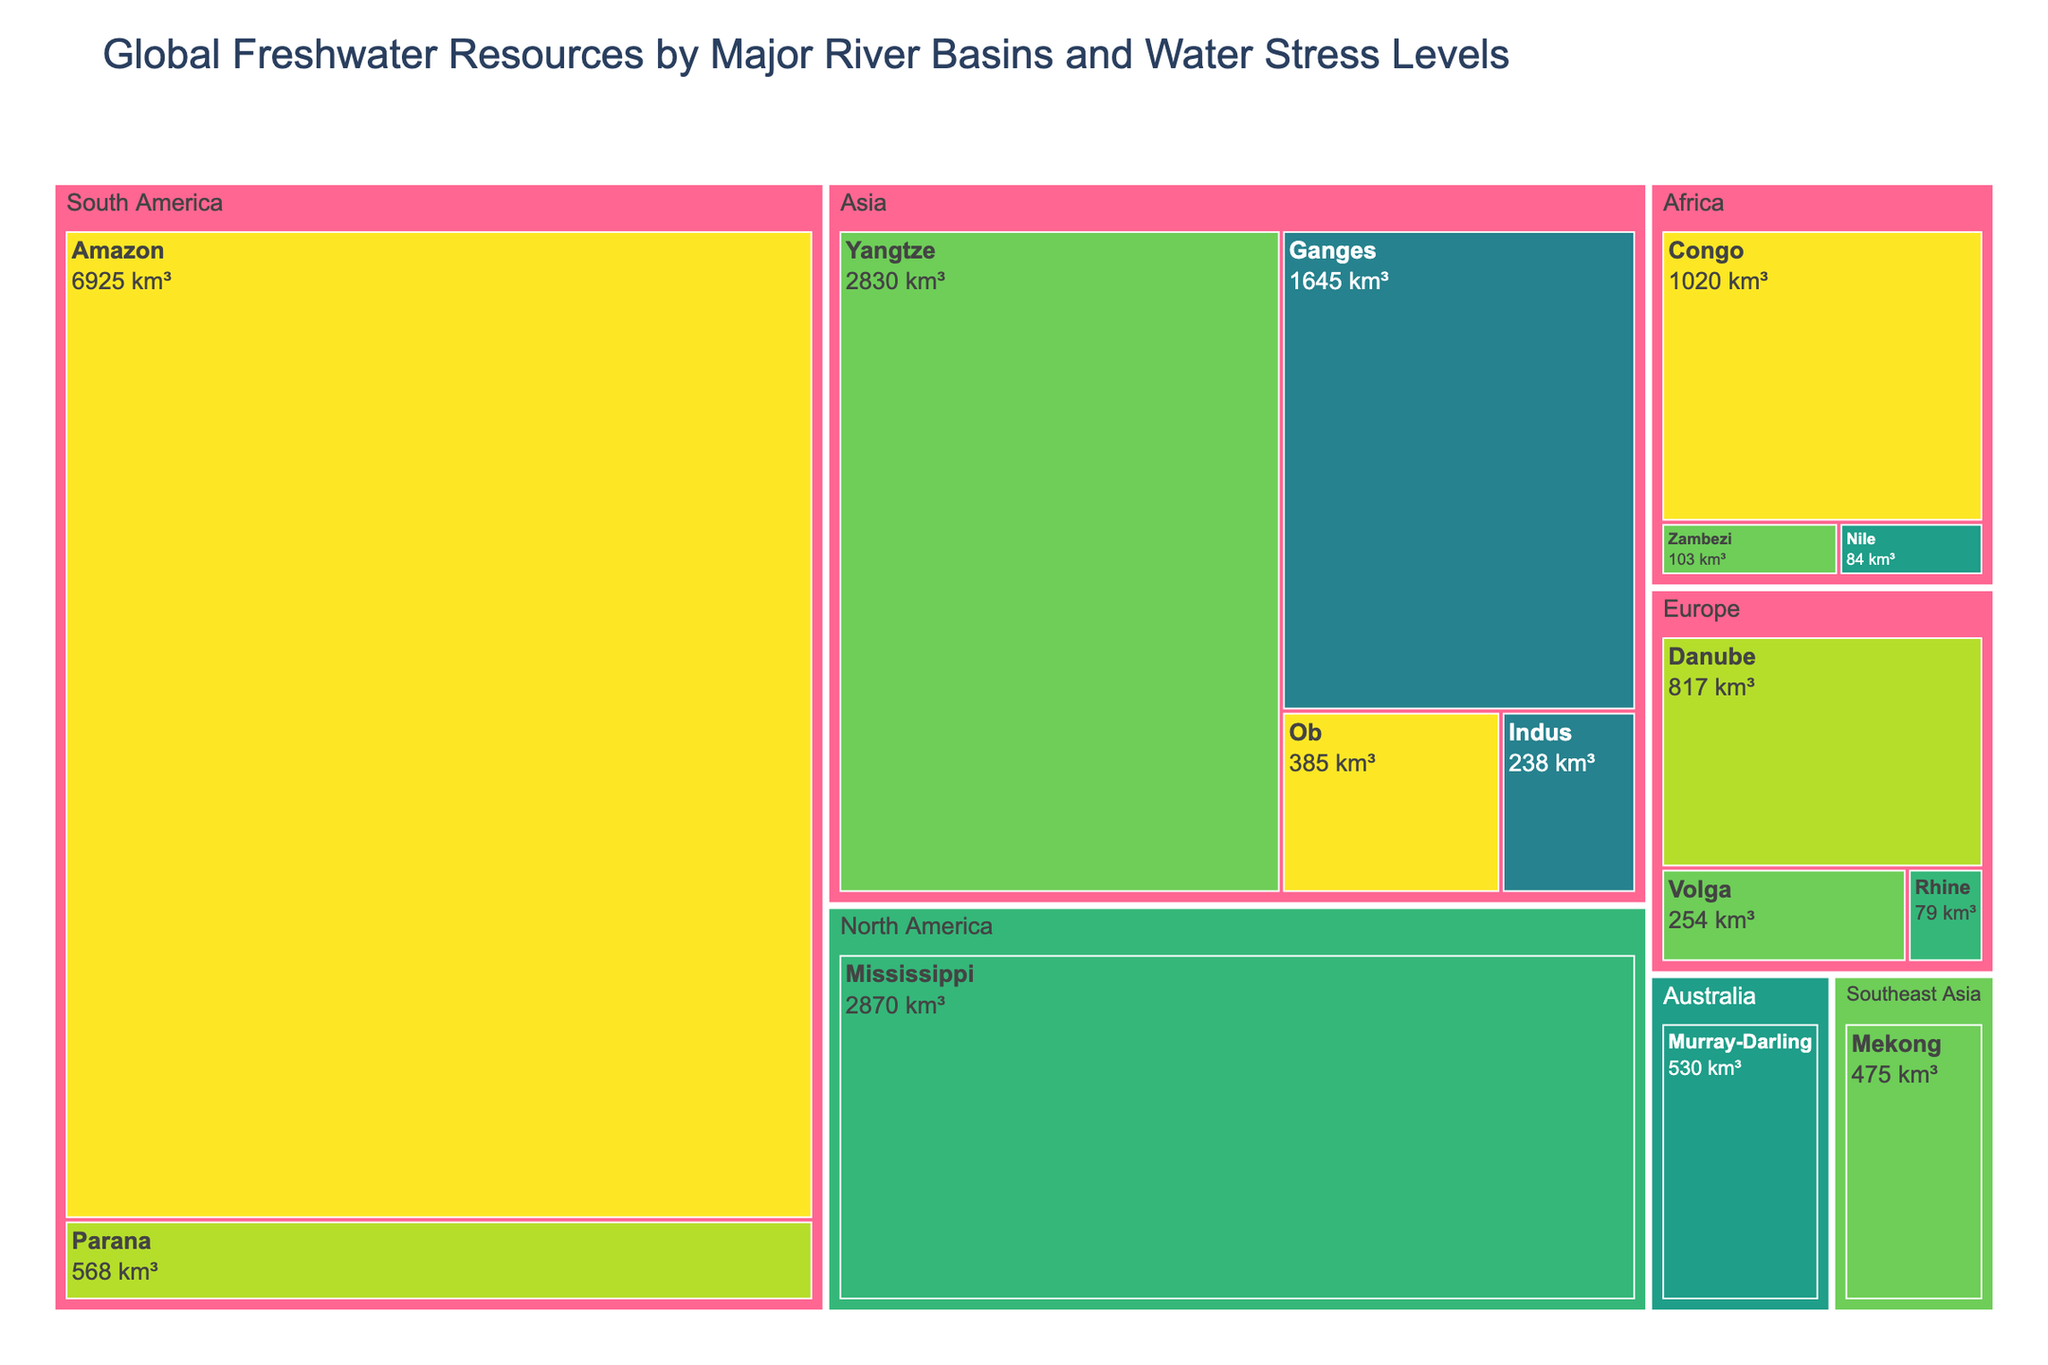How many river basins are shown in the treemap? Count the number of distinct river basins listed in the treemap. There are 15 river basins.
Answer: 15 Which river basin has the highest total freshwater resources? Examine the sizes and total freshwater values provided in the figure to identify which river basin has the largest value. The Amazon River basin has the highest total freshwater at 6925 km³.
Answer: Amazon In which region is the Niger River basin located? Look for the Niger River basin in the treemap and check the region it branches from. The Niger River basin is located in Africa.
Answer: Africa What is the total freshwater of the Danube River basin? Locate the Danube River basin in the figure and note its total freshwater value. The Danube River basin has 817 km3 of total freshwater.
Answer: 817 km3 Compare the water stress levels of the Ganges and the Mekong river basins. Which one has a higher water stress level? Identify the water stress levels of both the Ganges and Mekong river basins in the treemap. The Ganges has an extremely high water stress level, while the Mekong has a medium water stress level. Therefore, the Ganges has a higher water stress level.
Answer: Ganges Calculate the combined total freshwater resources of the Murray-Darling and the Indus river basins. Add the total freshwater resources of the Murray-Darling and Indus river basins. Murray-Darling has 530 km³ and Indus has 238 km³, so the sum is 530 + 238 = 768 km³.
Answer: 768 km³ Which river basin has the lowest total freshwater, and what is its water stress level? Find the river basin with the smallest total freshwater value and note its water stress level. The Nile River basin has the lowest total freshwater at 84 km³, and its water stress level is high.
Answer: Nile, High What is the average total freshwater of all river basins shown in the treemap? Calculate the average by summing all total freshwater values and dividing by the number of river basins. The sum of total freshwater values is 24,813 km³ (6925 + 1020 + 2830 + 2870 + 84 + 1645 + 475 + 817 + 530 + 254 + 238 + 79 + 103 + 385 + 568), and there are 15 river basins. Therefore, the average is 24,813 / 15 ≈ 1654.2 km³.
Answer: 1654.2 km³ How many river basins in the figure are located in Europe? Count the number of distinct river basins that branch from the Europe region in the treemap. There are 3 river basins located in Europe: Danube, Volga, and Rhine.
Answer: 3 Which river basin in North America has a higher total freshwater value? Determine the total freshwater values of river basins in North America and compare them. The Mississippi River basin has 2870 km³, which is higher than any other river basin in North America.
Answer: Mississippi 